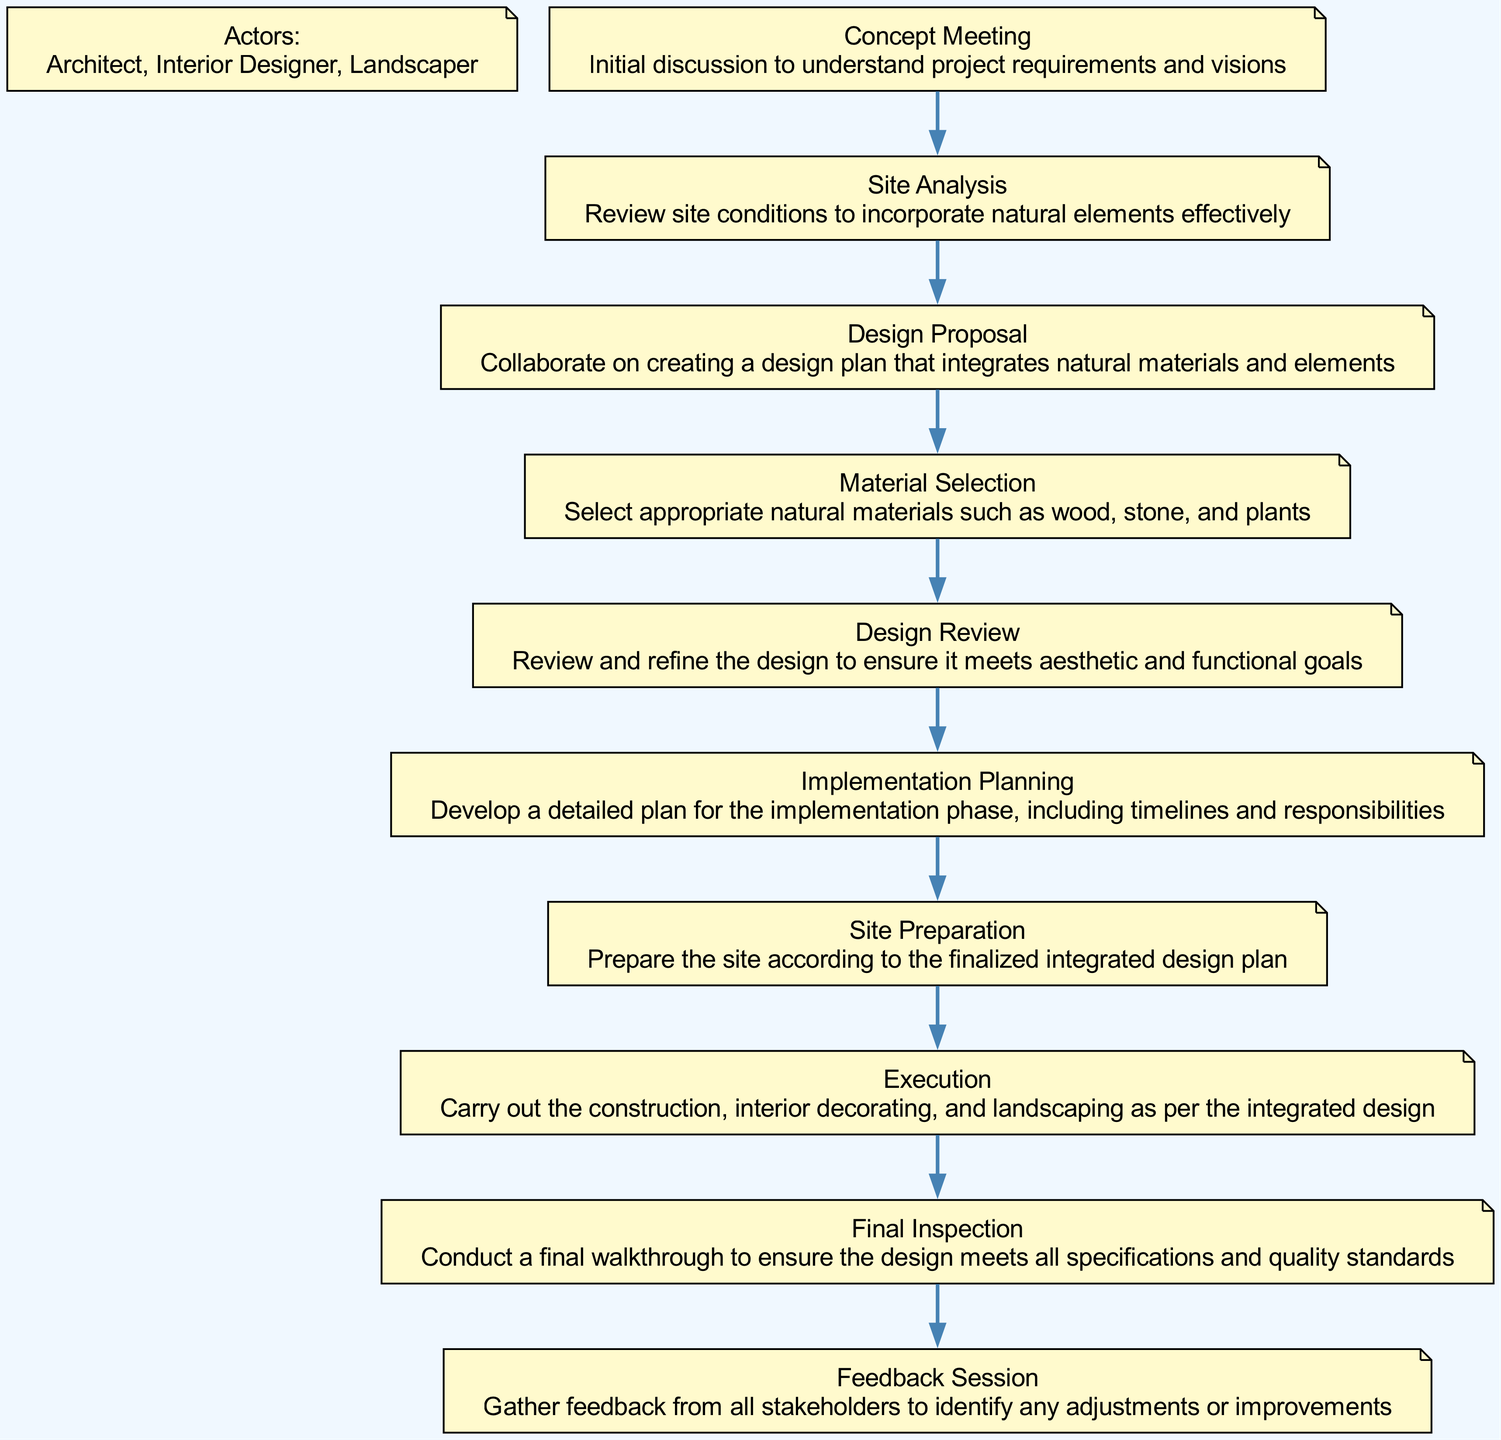What is the first activity in the diagram? The first activity is "Concept Meeting," as it is the starting point of the flow in the diagram. It leads to the next activity, "Site Analysis."
Answer: Concept Meeting How many actors are represented in the diagram? There are three actors listed in the diagram: Architect, Interior Designer, and Landscaper. Each actor plays a role in the process depicted.
Answer: 3 What activity follows "Material Selection"? The activity that follows "Material Selection" is "Design Review." This is indicated by a direct flow from "Material Selection" to "Design Review" in the diagram.
Answer: Design Review What is the last activity before the "Feedback Session"? The last activity before the "Feedback Session" is "Final Inspection." This is shown as a preceding activity in the flow leading to the "Feedback Session."
Answer: Final Inspection Which activities are part of the construction process? The activities that are part of the construction process include "Site Preparation" and "Execution." These involve tangible actions of preparing and constructing the site as per the design.
Answer: Site Preparation, Execution What is the total number of activities depicted in the diagram? The total number of activities depicted in the diagram is ten. Each activity represents a distinct step in the collaboration process.
Answer: 10 What is the purpose of the "Implementation Planning" activity? The purpose of "Implementation Planning" is to develop a detailed plan for the implementation phase, specifying timelines and responsibilities among the collaborators.
Answer: Develop a detailed plan Is the "Site Analysis" activity dependent on the "Concept Meeting"? Yes, "Site Analysis" is dependent on the "Concept Meeting" since it follows directly after it in the flow of the diagram, indicating it is reliant on the initial discussions.
Answer: Yes 